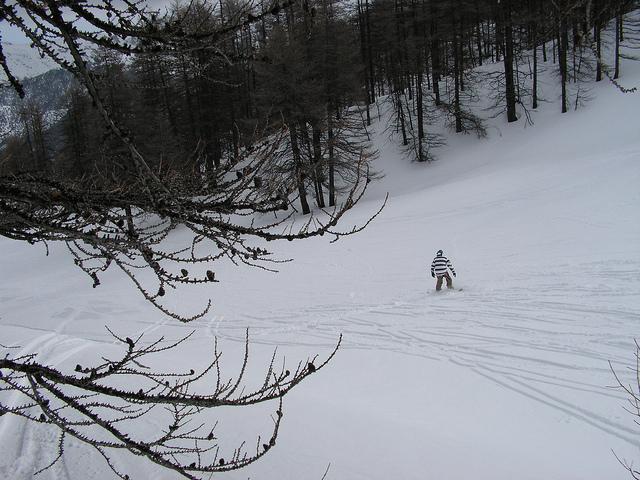Will the trees have leaves in a different season?
Keep it brief. Yes. Is he in soft snow?
Give a very brief answer. Yes. Is there any snow bunnies in this photo?
Write a very short answer. No. What is he doing?
Be succinct. Snowboarding. 